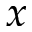Convert formula to latex. <formula><loc_0><loc_0><loc_500><loc_500>x</formula> 